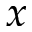Convert formula to latex. <formula><loc_0><loc_0><loc_500><loc_500>x</formula> 